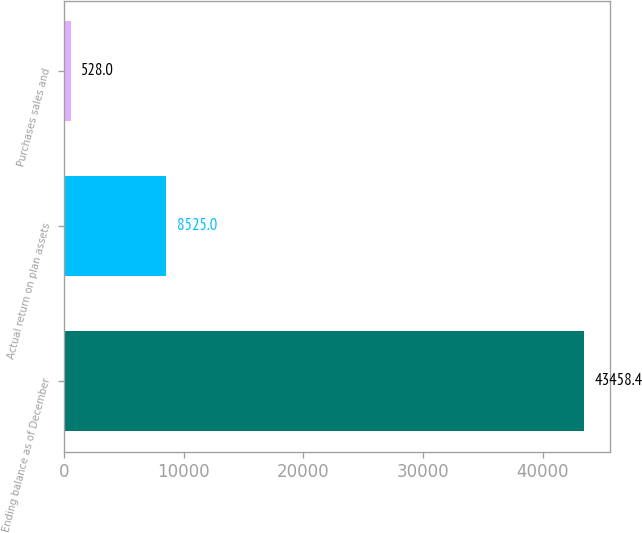Convert chart. <chart><loc_0><loc_0><loc_500><loc_500><bar_chart><fcel>Ending balance as of December<fcel>Actual return on plan assets<fcel>Purchases sales and<nl><fcel>43458.4<fcel>8525<fcel>528<nl></chart> 